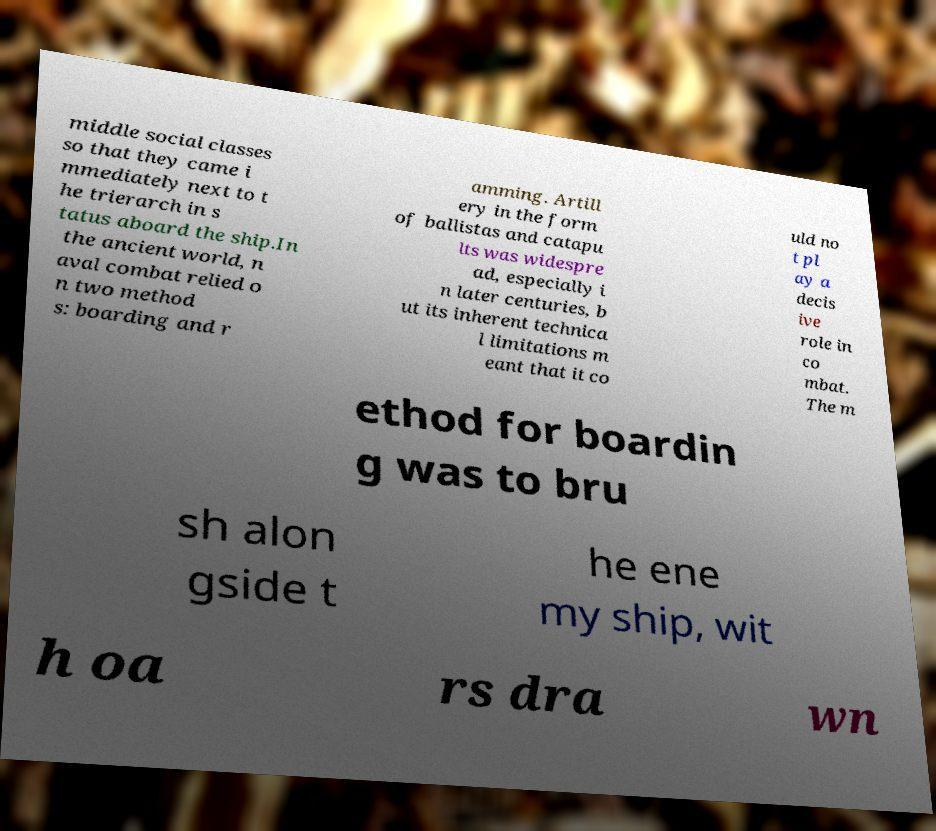Please identify and transcribe the text found in this image. middle social classes so that they came i mmediately next to t he trierarch in s tatus aboard the ship.In the ancient world, n aval combat relied o n two method s: boarding and r amming. Artill ery in the form of ballistas and catapu lts was widespre ad, especially i n later centuries, b ut its inherent technica l limitations m eant that it co uld no t pl ay a decis ive role in co mbat. The m ethod for boardin g was to bru sh alon gside t he ene my ship, wit h oa rs dra wn 